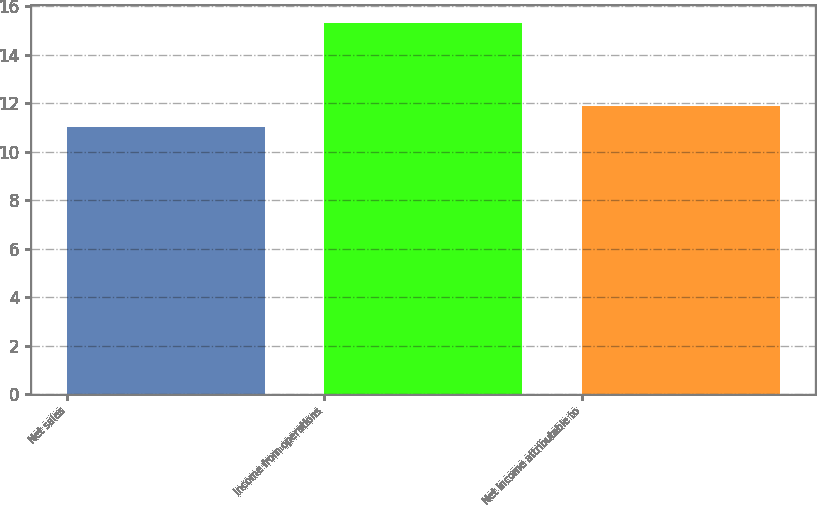<chart> <loc_0><loc_0><loc_500><loc_500><bar_chart><fcel>Net sales<fcel>Income from operations<fcel>Net income attributable to<nl><fcel>11<fcel>15.3<fcel>11.9<nl></chart> 